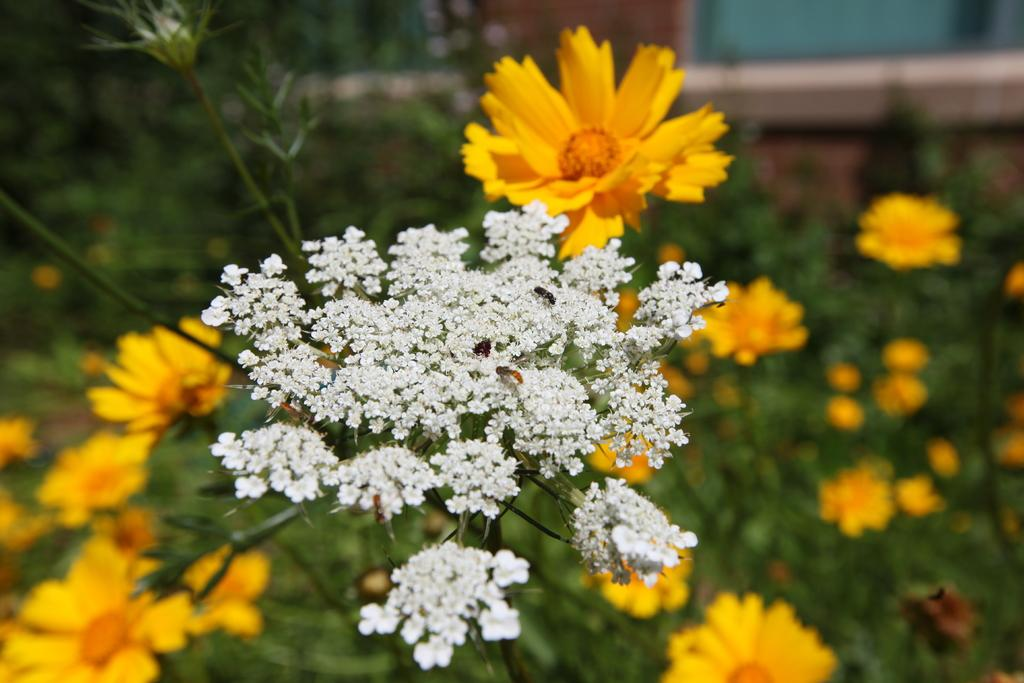What type of plants are visible in the image? There are plants with flowers in the image. Where are the leaves located in the image? The leaves are in the left corner of the image. What can be seen in the background of the image? There appears to be a building in the background of the image. Where are the tomatoes growing in the image? There are no tomatoes present in the image. 